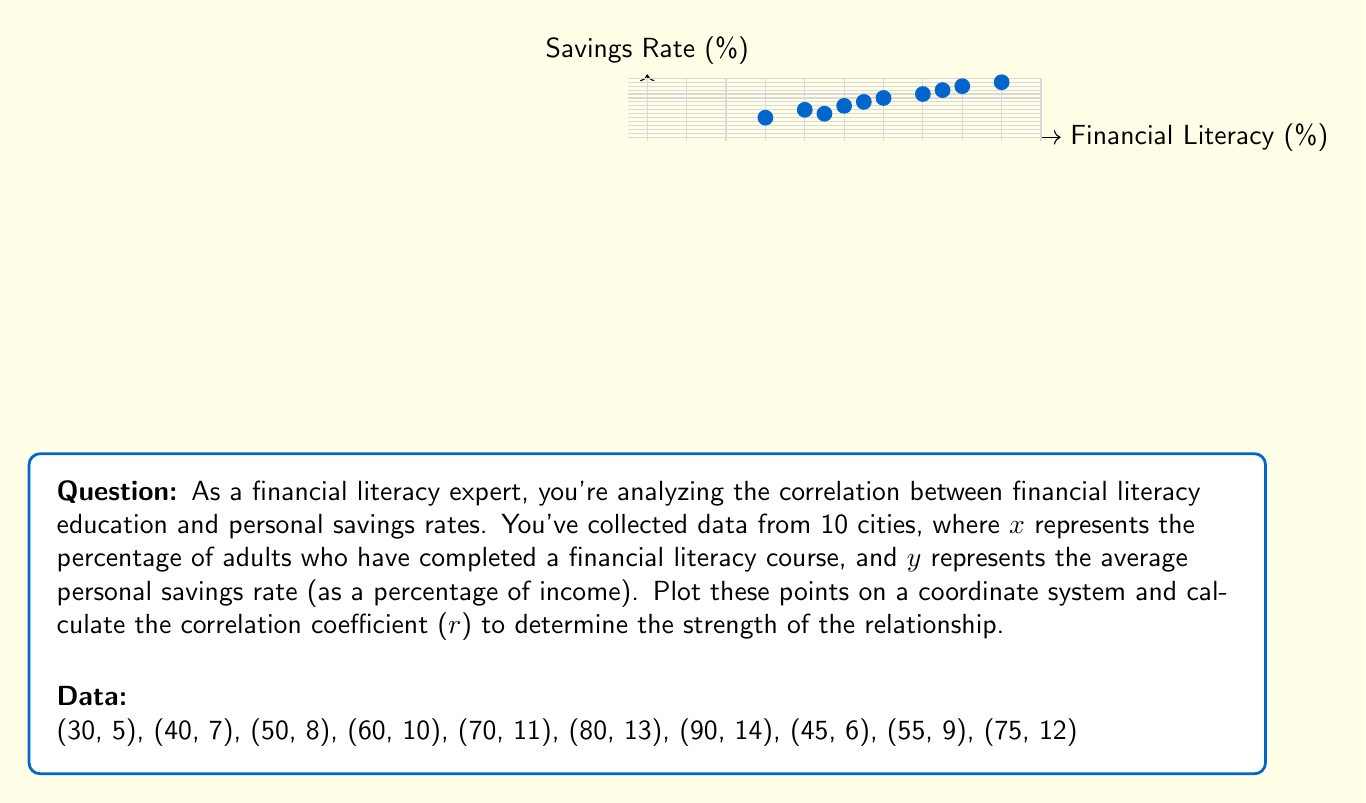Help me with this question. To calculate the correlation coefficient (r), we'll use the formula:

$$ r = \frac{n\sum xy - (\sum x)(\sum y)}{\sqrt{[n\sum x^2 - (\sum x)^2][n\sum y^2 - (\sum y)^2]}} $$

Where n is the number of data points.

Step 1: Calculate the necessary sums:
$n = 10$
$\sum x = 595$
$\sum y = 95$
$\sum xy = 5,985$
$\sum x^2 = 38,025$
$\sum y^2 = 971$

Step 2: Substitute these values into the formula:

$$ r = \frac{10(5,985) - (595)(95)}{\sqrt{[10(38,025) - 595^2][10(971) - 95^2]}} $$

Step 3: Simplify:

$$ r = \frac{59,850 - 56,525}{\sqrt{(380,250 - 354,025)(9,710 - 9,025)}} $$

$$ r = \frac{3,325}{\sqrt{(26,225)(685)}} $$

$$ r = \frac{3,325}{\sqrt{17,964,125}} $$

$$ r = \frac{3,325}{4,237.7} $$

Step 4: Calculate the final result:

$$ r \approx 0.7845 $$

This result indicates a strong positive correlation between financial literacy education and personal savings rates.
Answer: $r \approx 0.7845$ 